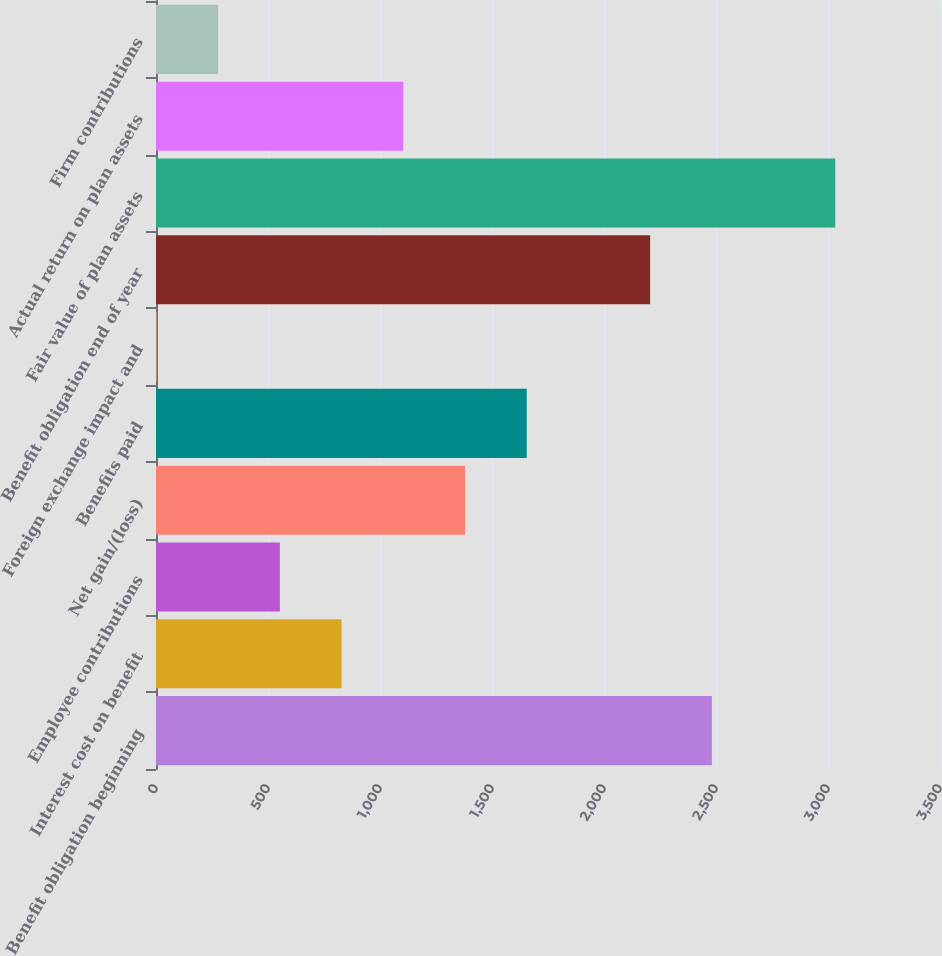<chart> <loc_0><loc_0><loc_500><loc_500><bar_chart><fcel>Benefit obligation beginning<fcel>Interest cost on benefit<fcel>Employee contributions<fcel>Net gain/(loss)<fcel>Benefits paid<fcel>Foreign exchange impact and<fcel>Benefit obligation end of year<fcel>Fair value of plan assets<fcel>Actual return on plan assets<fcel>Firm contributions<nl><fcel>2481.5<fcel>828.5<fcel>553<fcel>1379.5<fcel>1655<fcel>2<fcel>2206<fcel>3032.5<fcel>1104<fcel>277.5<nl></chart> 